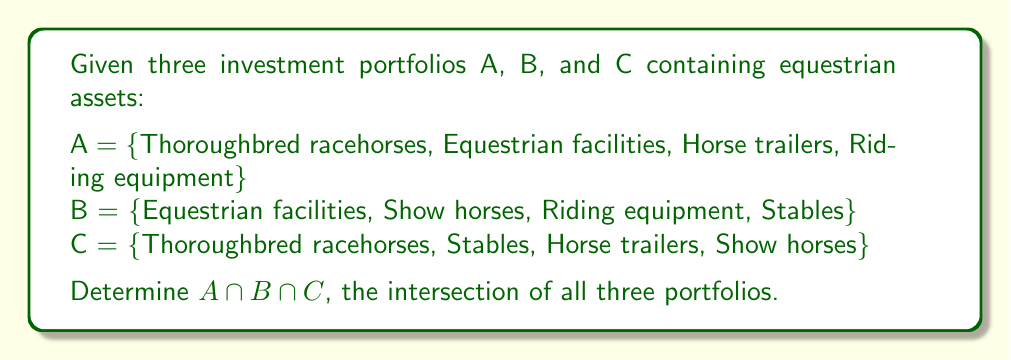Show me your answer to this math problem. To find the intersection of all three sets, we need to identify the elements that are common to all three portfolios. Let's approach this step-by-step:

1. First, let's list out each set:
   A = {Thoroughbred racehorses, Equestrian facilities, Horse trailers, Riding equipment}
   B = {Equestrian facilities, Show horses, Riding equipment, Stables}
   C = {Thoroughbred racehorses, Stables, Horse trailers, Show horses}

2. Now, let's identify the elements that appear in all three sets:
   - Thoroughbred racehorses: in A and C, but not in B
   - Equestrian facilities: in A and B, but not in C
   - Horse trailers: in A and C, but not in B
   - Riding equipment: in A and B, but not in C
   - Show horses: in B and C, but not in A
   - Stables: in B and C, but not in A

3. As we can see, there are no elements that appear in all three sets.

Therefore, the intersection of A, B, and C is the empty set, denoted by $\emptyset$ or {}.

In set theory notation:
$$A \cap B \cap C = \emptyset$$
Answer: $A \cap B \cap C = \emptyset$ 